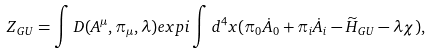Convert formula to latex. <formula><loc_0><loc_0><loc_500><loc_500>Z _ { G U } = \int D ( A ^ { \mu } , \pi _ { \mu } , \lambda ) e x p i \int d ^ { 4 } x ( \pi _ { 0 } \dot { A } _ { 0 } + \pi _ { i } \dot { A } _ { i } - \widetilde { H } _ { G U } - \lambda \chi ) ,</formula> 